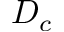<formula> <loc_0><loc_0><loc_500><loc_500>D _ { c }</formula> 